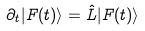Convert formula to latex. <formula><loc_0><loc_0><loc_500><loc_500>\partial _ { t } | F ( t ) \rangle = \hat { L } | F ( t ) \rangle</formula> 